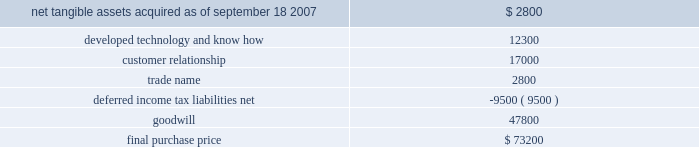Table of contents hologic , inc .
Notes to consolidated financial statements ( continued ) ( in thousands , except per share data ) the acquisition also provides for up to two annual earn-out payments not to exceed $ 15000 in the aggregate based on biolucent 2019s achievement of certain revenue targets .
The company considered the provision of eitf 95-8 , and concluded that this contingent consideration represents additional purchase price .
As a result , goodwill will be increased by the amount of the additional consideration , if any , as it is earned .
As of september 26 , 2009 , the company has not recorded any amounts for these potential earn-outs .
The allocation of the purchase price was based upon estimates of the fair value of assets acquired and liabilities assumed as of september 18 , 2007 .
The components and allocation of the purchase price consisted of the following approximate amounts: .
As part of the purchase price allocation , all intangible assets that were a part of the acquisition were identified and valued .
It was determined that only customer relationship , trade name and developed technology had separately identifiable values .
The fair value of these intangible assets was determined through the application of the income approach .
Customer relationship represented a large customer base that was expected to purchase the disposable mammopad product on a regular basis .
Trade name represented the biolucent product name that the company intended to continue to use .
Developed technology represented currently marketable purchased products that the company continues to sell as well as utilize to enhance and incorporate into the company 2019s existing products .
The deferred income tax liability relates to the tax effect of acquired identifiable intangible assets and fair value adjustments to acquired inventory , as such amounts are not deductible for tax purposes , partially offset by acquired net operating loss carryforwards of approximately $ 2400 .
Sale of gestiva on january 16 , 2008 , the company entered into a definitive agreement pursuant to which it agreed to sell full u.s .
And world-wide rights to gestiva to k-v pharmaceutical company upon approval of the pending gestiva new drug application ( the 201cgestiva nda 201d ) by the fda for a purchase price of $ 82000 .
The company received $ 9500 of the purchase price in fiscal 2008 , and the balance is due upon final approval of the gestiva nda by the fda on or before february 19 , 2010 and the production of a quantity of gestiva suitable to enable the commercial launch of the product .
Either party has the right to terminate the agreement if fda approval is not obtained by february 19 , 2010 .
The company agreed to continue its efforts to obtain fda approval of the nda for gestiva as part of this arrangement .
All costs incurred in these efforts will be reimbursed by k-v pharmaceutical and are being recorded as a credit against research and development expenses .
During fiscal 2009 and 2008 , these reimbursed costs were not material .
The company recorded the $ 9500 as a deferred gain within current liabilities in the consolidated balance sheet .
The company expects that the gain will be recognized upon the closing of the transaction following final fda approval of the gestiva nda or if the agreement is terminated .
The company cannot assure that it will be able to obtain the requisite fda approval , that the transaction will be completed or that it will receive the balance of the purchase price .
Moreover , if k-v pharmaceutical terminates the agreement as a result of a breach by the company of a material representation , warranty , covenant or agreement , the company will be required to return the funds previously received as well as expenses reimbursed by k-v .
Source : hologic inc , 10-k , november 24 , 2009 powered by morningstar ae document research 2120 the information contained herein may not be copied , adapted or distributed and is not warranted to be accurate , complete or timely .
The user assumes all risks for any damages or losses arising from any use of this information , except to the extent such damages or losses cannot be limited or excluded by applicable law .
Past financial performance is no guarantee of future results. .
What portion of the final purchase price is related to goodwill? 
Computations: (47800 / 73200)
Answer: 0.65301. 